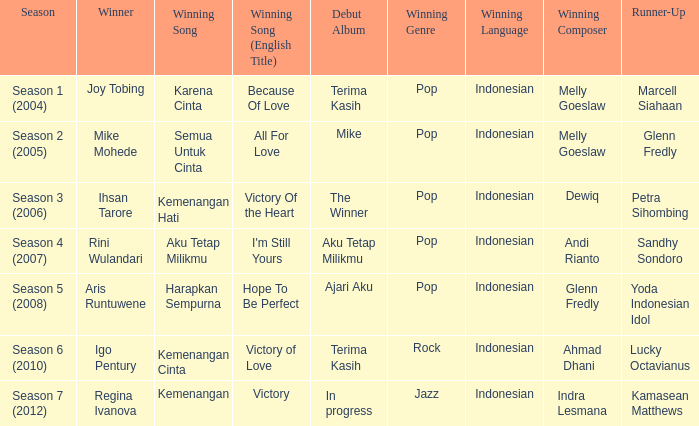Which winning song had a debut album in progress? Kemenangan. 